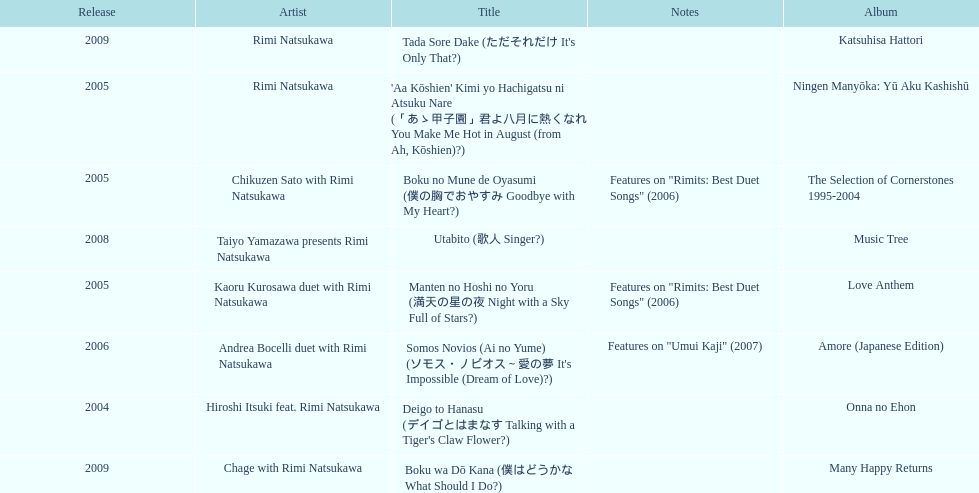Which was released earlier, deigo to hanasu or utabito? Deigo to Hanasu. 